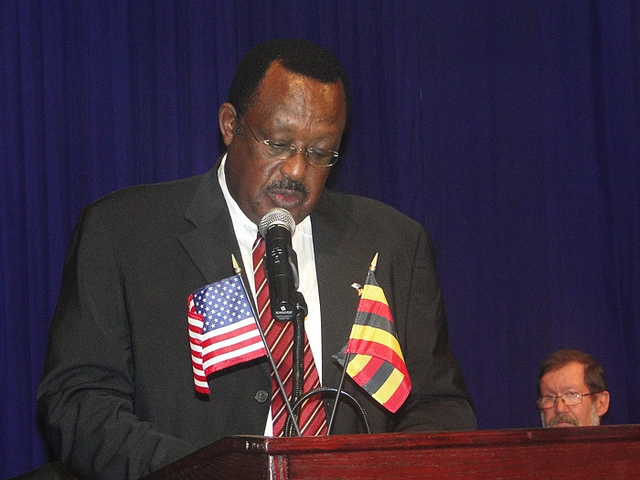<image>What countries do the flags represent? I don't know all the countries the flags represent. However, USA seems to be represented. What countries do the flags represent? I am not sure what countries the flags represent. However, it can be seen that the flags represent the United States and some other African nations. 